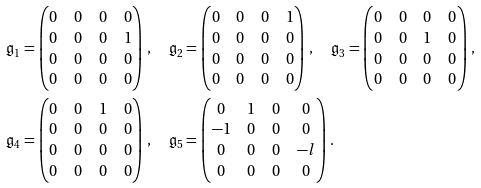<formula> <loc_0><loc_0><loc_500><loc_500>& \mathfrak { g } _ { 1 } = \begin{pmatrix} 0 & 0 & 0 & 0 \\ 0 & 0 & 0 & 1 \\ 0 & 0 & 0 & 0 \\ 0 & 0 & 0 & 0 \\ \end{pmatrix} \, , \quad \mathfrak { g } _ { 2 } = \begin{pmatrix} 0 & 0 & 0 & 1 \\ 0 & 0 & 0 & 0 \\ 0 & 0 & 0 & 0 \\ 0 & 0 & 0 & 0 \\ \end{pmatrix} \, , \quad \mathfrak { g } _ { 3 } = \begin{pmatrix} 0 & 0 & 0 & 0 \\ 0 & 0 & 1 & 0 \\ 0 & 0 & 0 & 0 \\ 0 & 0 & 0 & 0 \\ \end{pmatrix} \, , \\ & \mathfrak { g } _ { 4 } = \begin{pmatrix} 0 & 0 & 1 & 0 \\ 0 & 0 & 0 & 0 \\ 0 & 0 & 0 & 0 \\ 0 & 0 & 0 & 0 \\ \end{pmatrix} \, , \quad \mathfrak { g } _ { 5 } = \begin{pmatrix} 0 & 1 & 0 & 0 \\ - 1 & 0 & 0 & 0 \\ 0 & 0 & 0 & - l \\ 0 & 0 & 0 & 0 \\ \end{pmatrix} \, .</formula> 